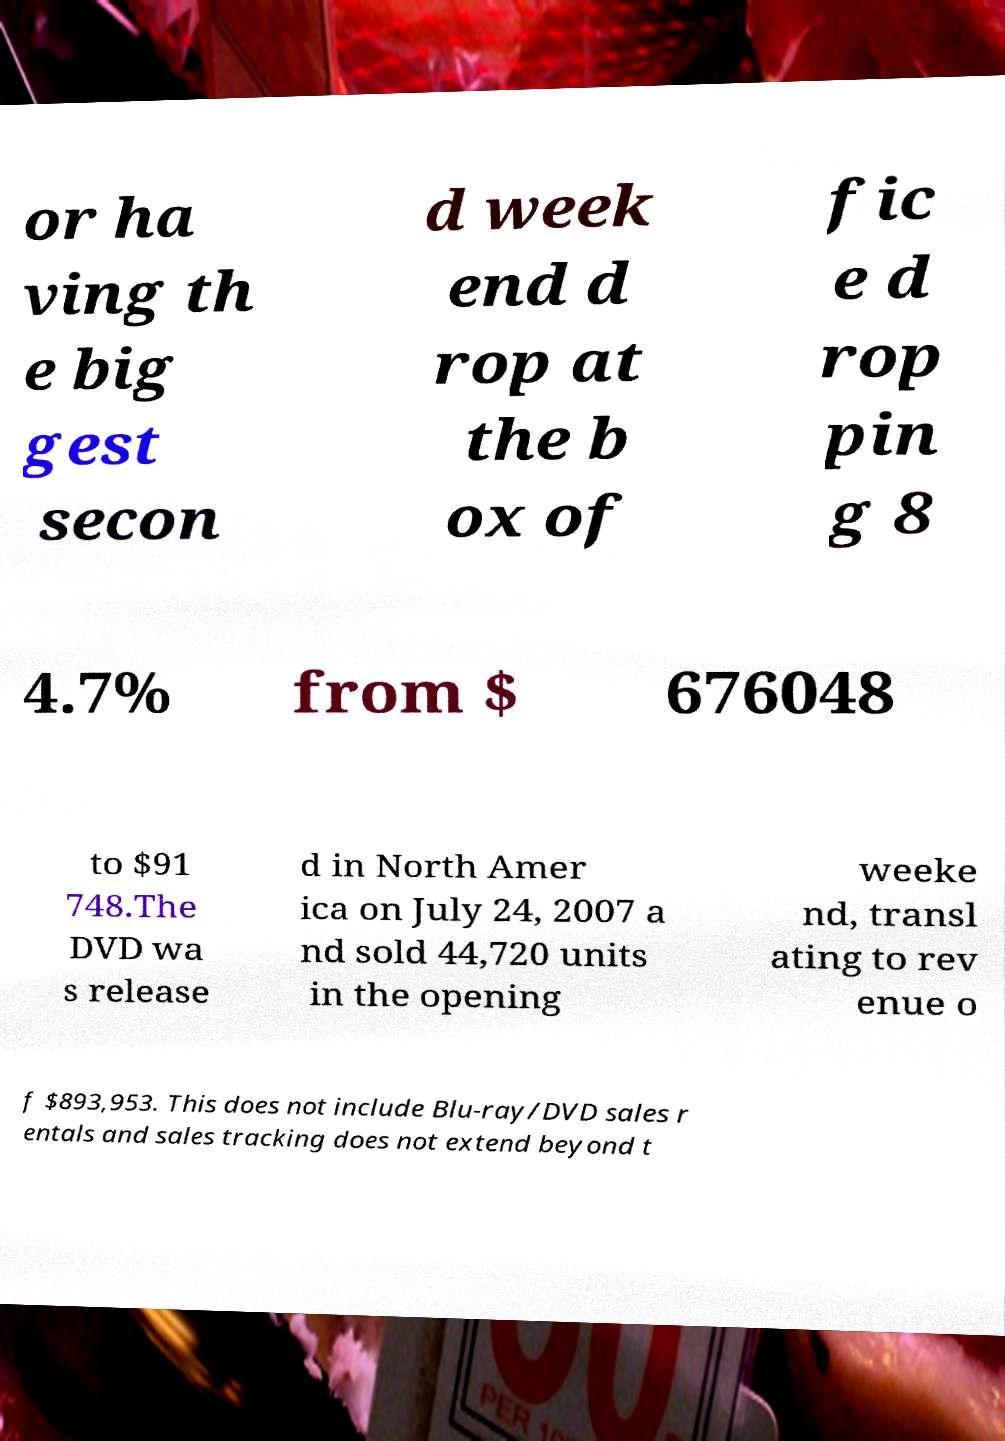Could you extract and type out the text from this image? or ha ving th e big gest secon d week end d rop at the b ox of fic e d rop pin g 8 4.7% from $ 676048 to $91 748.The DVD wa s release d in North Amer ica on July 24, 2007 a nd sold 44,720 units in the opening weeke nd, transl ating to rev enue o f $893,953. This does not include Blu-ray/DVD sales r entals and sales tracking does not extend beyond t 